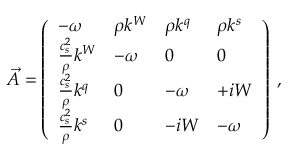Convert formula to latex. <formula><loc_0><loc_0><loc_500><loc_500>\vec { A } = \left ( \begin{array} { l l l l } { - { \omega } } & { \rho k ^ { W } } & { \rho k ^ { q } } & { \rho k ^ { s } } \\ { \frac { c _ { s } ^ { 2 } } { \rho } k ^ { W } } & { - { \omega } } & { 0 } & { 0 } \\ { \frac { c _ { s } ^ { 2 } } { \rho } k ^ { q } } & { 0 } & { - { \omega } } & { + i W } \\ { \frac { c _ { s } ^ { 2 } } { \rho } k ^ { s } } & { 0 } & { - i W } & { - { \omega } } \end{array} \right ) \, ,</formula> 